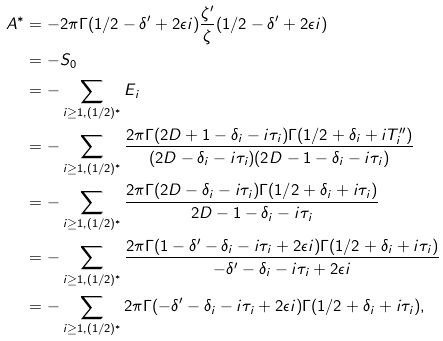Convert formula to latex. <formula><loc_0><loc_0><loc_500><loc_500>A ^ { * } & = - 2 \pi \Gamma ( 1 / 2 - \delta ^ { \prime } + 2 \epsilon i ) \frac { \zeta ^ { \prime } } { \zeta } ( 1 / 2 - \delta ^ { \prime } + 2 \epsilon i ) \\ & = - S _ { 0 } \\ & = - \sum _ { i \geq 1 , ( 1 / 2 ) ^ { * } } E _ { i } \\ & = - \sum _ { i \geq 1 , ( 1 / 2 ) ^ { * } } \frac { 2 \pi \Gamma ( 2 D + 1 - \delta _ { i } - i \tau _ { i } ) \Gamma ( 1 / 2 + \delta _ { i } + i T _ { i } ^ { \prime \prime } ) } { ( 2 D - \delta _ { i } - i \tau _ { i } ) ( 2 D - 1 - \delta _ { i } - i \tau _ { i } ) } \\ & = - \sum _ { i \geq 1 , ( 1 / 2 ) ^ { * } } \frac { 2 \pi \Gamma ( 2 D - \delta _ { i } - i \tau _ { i } ) \Gamma ( 1 / 2 + \delta _ { i } + i \tau _ { i } ) } { 2 D - 1 - \delta _ { i } - i \tau _ { i } } \\ & = - \sum _ { i \geq 1 , ( 1 / 2 ) ^ { * } } \frac { 2 \pi \Gamma ( 1 - \delta ^ { \prime } - \delta _ { i } - i \tau _ { i } + 2 \epsilon i ) \Gamma ( 1 / 2 + \delta _ { i } + i \tau _ { i } ) } { - \delta ^ { \prime } - \delta _ { i } - i \tau _ { i } + 2 \epsilon i } \\ & = - \sum _ { i \geq 1 , ( 1 / 2 ) ^ { * } } 2 \pi \Gamma ( - \delta ^ { \prime } - \delta _ { i } - i \tau _ { i } + 2 \epsilon i ) \Gamma ( 1 / 2 + \delta _ { i } + i \tau _ { i } ) ,</formula> 